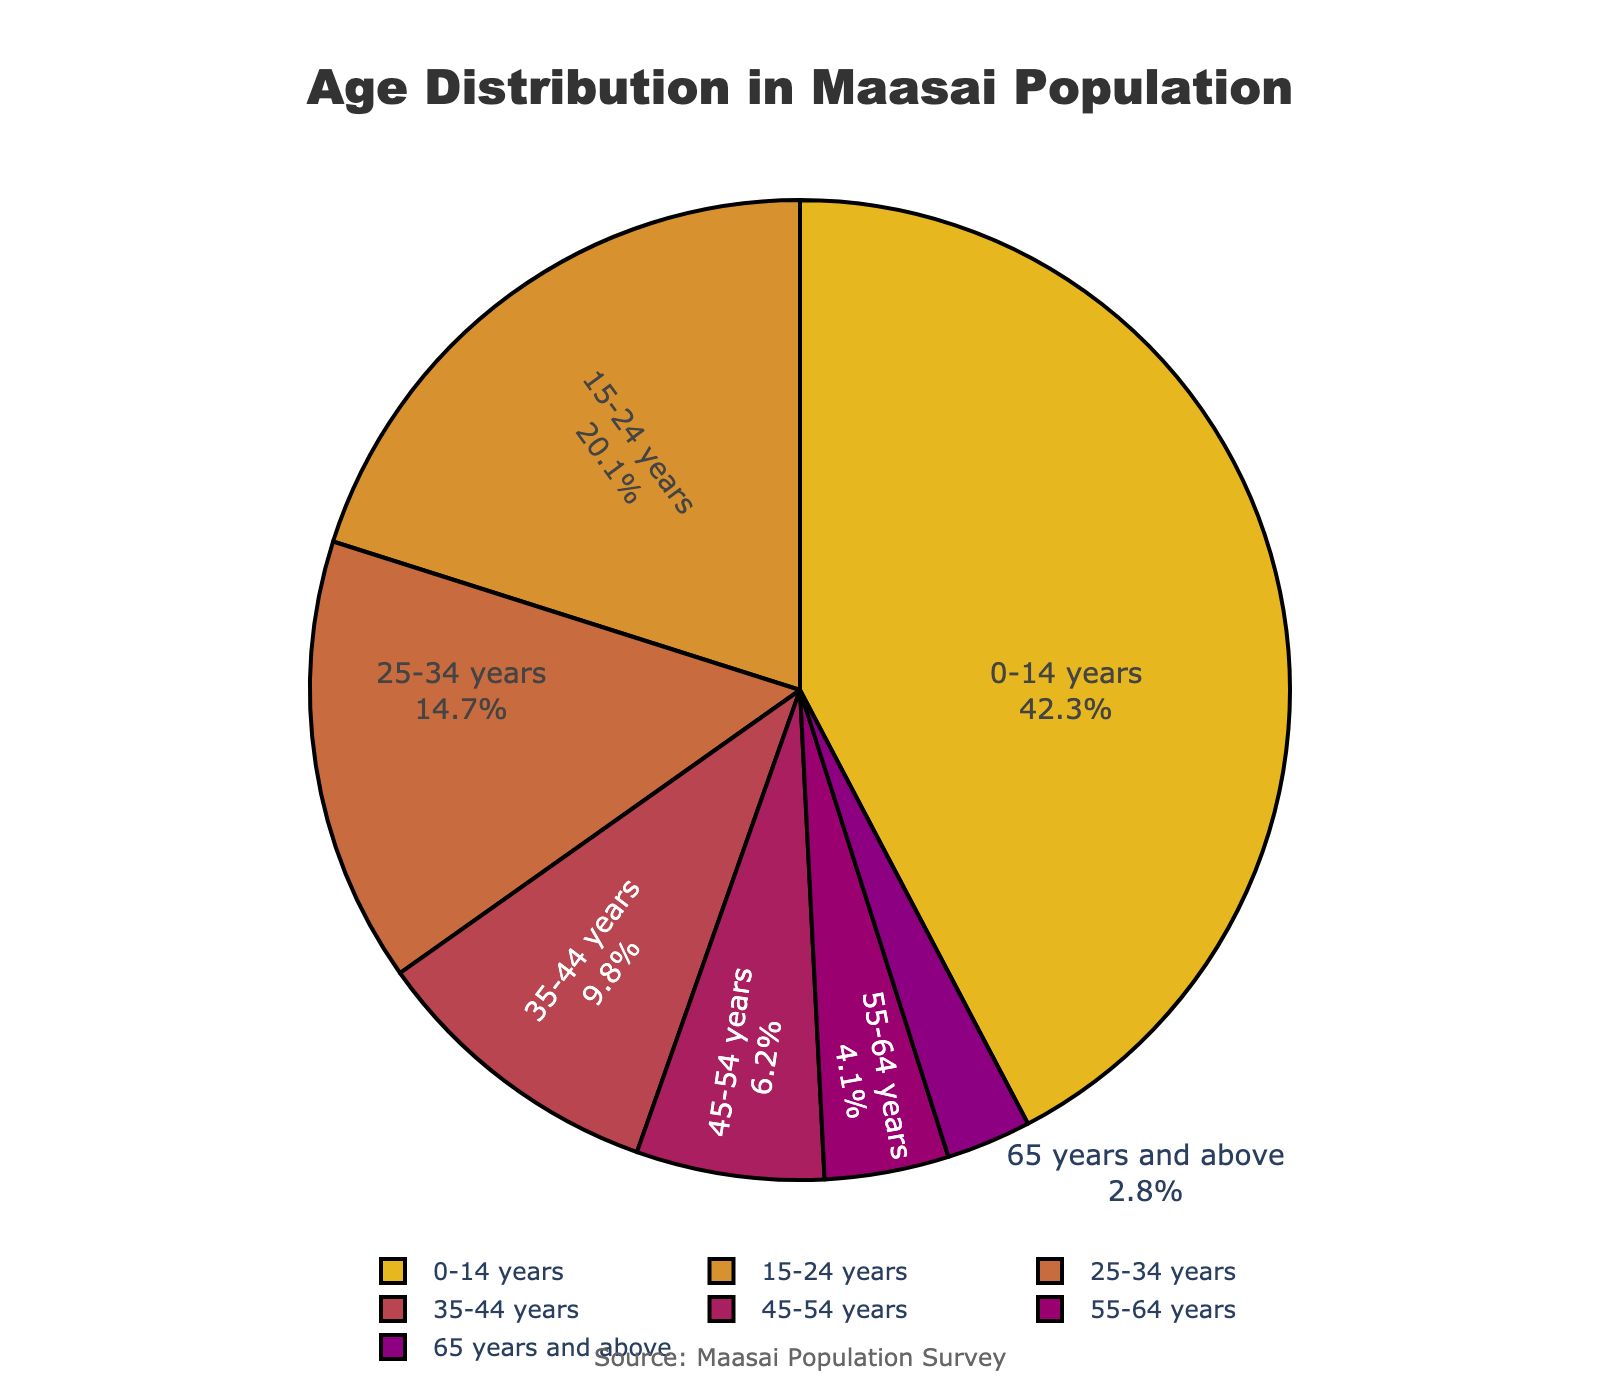Which age group has the largest percentage in the Maasai population? By looking at the pie chart, we can see that the largest section is labeled "0-14 years", which accounts for 42.3% of the population.
Answer: 0-14 years Which two age groups together account for less than 10% of the Maasai population? By examining the labels and percentages, we find that the age groups "55-64 years" (4.1%) and "65 years and above" (2.8%) together sum up to 6.9%, which is less than 10%.
Answer: 55-64 years and 65 years and above What is the difference in percentage between the "15-24 years" and "35-44 years" age groups? The percentage for "15-24 years" is 20.1%, and for "35-44 years", it is 9.8%. The difference between them is calculated as 20.1% - 9.8% = 10.3%.
Answer: 10.3% How many age groups have a percentage that is less than 10% of the Maasai population? We need to count all the age groups with a percentage under 10%. These are "35-44 years" (9.8%), "45-54 years" (6.2%), "55-64 years" (4.1%), and "65 years and above" (2.8%). There are 4 such groups.
Answer: 4 Which colors represent the "25-34 years" and "45-54 years" age groups in the pie chart? Referring to the color assignment in the pie chart, the "25-34 years" group is colored in a reddish hue, while the "45-54 years" group is represented in a purplish hue.
Answer: "25-34 years" is reddish, and "45-54 years" is purplish Between the age groups "15-24 years" and "0-14 years," which one constitutes a smaller portion of the Maasai population? The pie chart shows that "15-24 years" constitutes 20.1%, while "0-14 years" constitutes 42.3%. Since 20.1 is smaller than 42.3, "15-24 years" makes up a smaller portion.
Answer: 15-24 years What is the combined percentage of the "25-34 years" and "35-44 years" age groups? The percentage for "25-34 years" is 14.7%, and for "35-44 years", it is 9.8%. Adding these together gives 14.7% + 9.8% = 24.5%.
Answer: 24.5% If you consider the age groups "0-14 years", "15-24 years", and "25-34 years", what is their total percentage of the Maasai population? Summing the percentages for "0-14 years" (42.3%), "15-24 years" (20.1%), and "25-34 years" (14.7%) results in a combined total of 42.3% + 20.1% + 14.7% = 77.1%.
Answer: 77.1% 